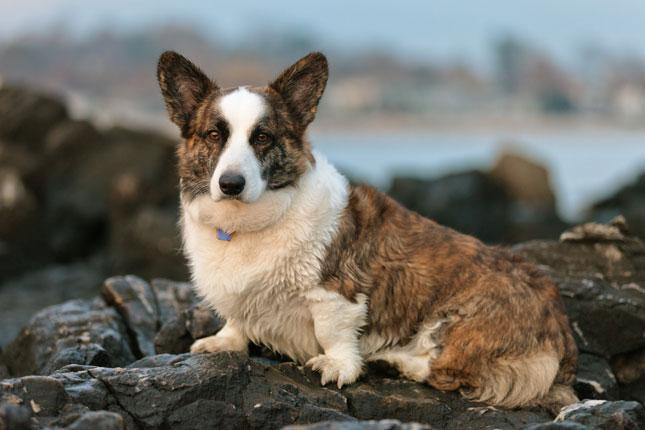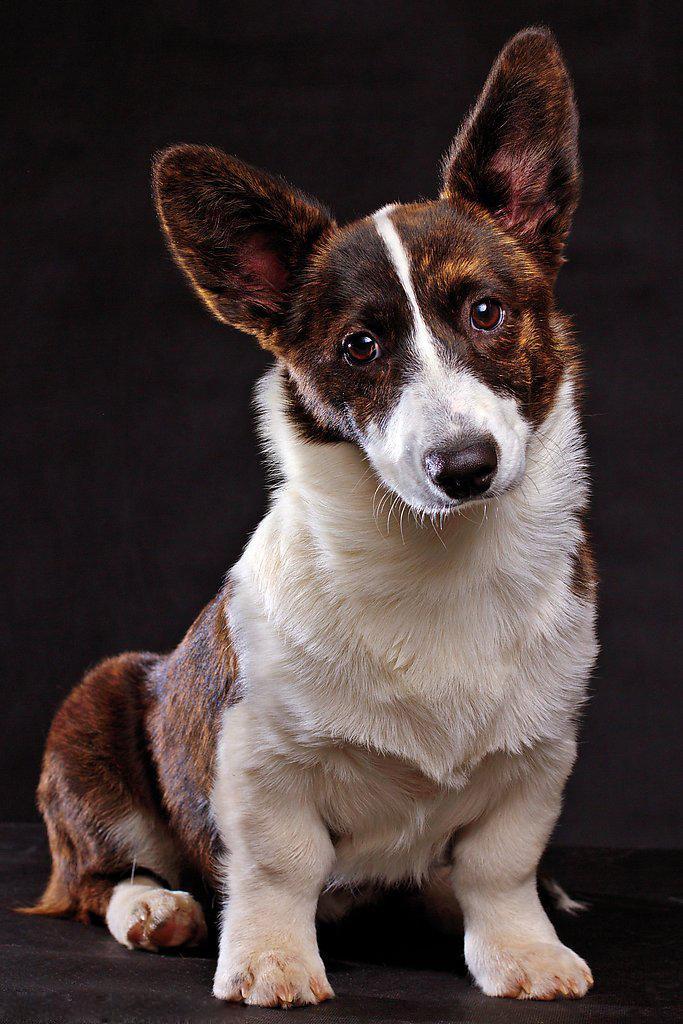The first image is the image on the left, the second image is the image on the right. Considering the images on both sides, is "There are at most two dogs." valid? Answer yes or no. Yes. The first image is the image on the left, the second image is the image on the right. Evaluate the accuracy of this statement regarding the images: "There are exactly two dogs.". Is it true? Answer yes or no. Yes. 